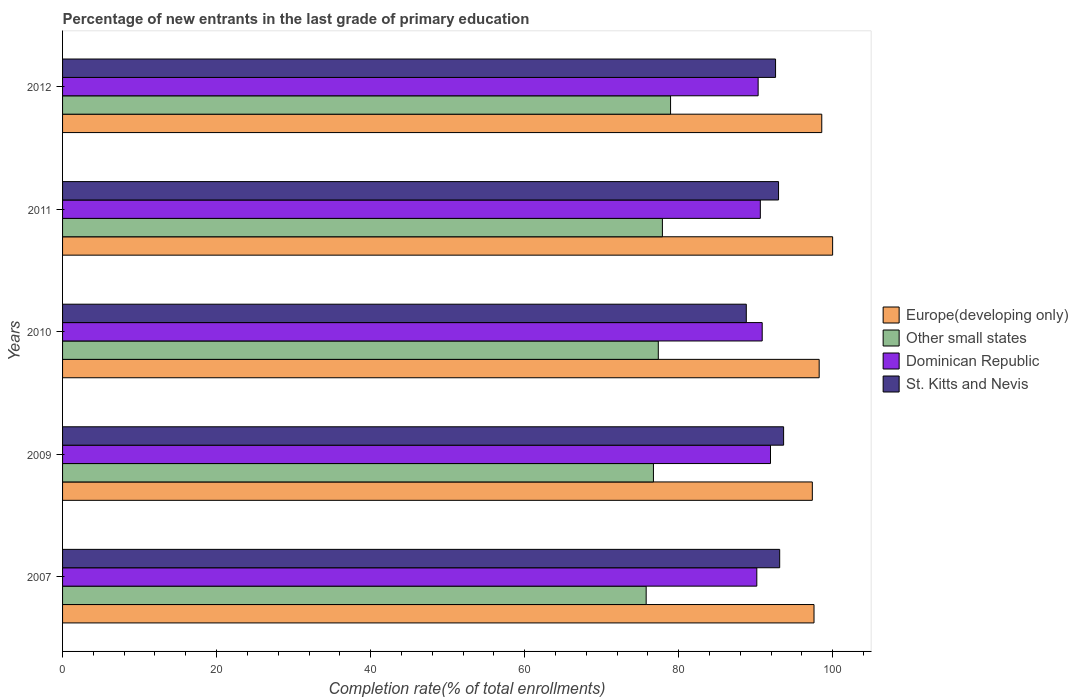Are the number of bars per tick equal to the number of legend labels?
Provide a short and direct response. Yes. Are the number of bars on each tick of the Y-axis equal?
Provide a short and direct response. Yes. How many bars are there on the 4th tick from the top?
Offer a very short reply. 4. How many bars are there on the 3rd tick from the bottom?
Ensure brevity in your answer.  4. What is the label of the 4th group of bars from the top?
Offer a terse response. 2009. In how many cases, is the number of bars for a given year not equal to the number of legend labels?
Offer a terse response. 0. What is the percentage of new entrants in Europe(developing only) in 2007?
Provide a short and direct response. 97.56. Across all years, what is the maximum percentage of new entrants in Europe(developing only)?
Your answer should be very brief. 99.98. Across all years, what is the minimum percentage of new entrants in St. Kitts and Nevis?
Provide a short and direct response. 88.77. What is the total percentage of new entrants in Other small states in the graph?
Make the answer very short. 386.66. What is the difference between the percentage of new entrants in Other small states in 2010 and that in 2011?
Give a very brief answer. -0.53. What is the difference between the percentage of new entrants in Dominican Republic in 2010 and the percentage of new entrants in St. Kitts and Nevis in 2011?
Offer a terse response. -2.12. What is the average percentage of new entrants in Dominican Republic per year?
Keep it short and to the point. 90.76. In the year 2011, what is the difference between the percentage of new entrants in Europe(developing only) and percentage of new entrants in Other small states?
Provide a succinct answer. 22.1. What is the ratio of the percentage of new entrants in Dominican Republic in 2009 to that in 2011?
Offer a very short reply. 1.01. What is the difference between the highest and the second highest percentage of new entrants in St. Kitts and Nevis?
Offer a terse response. 0.51. What is the difference between the highest and the lowest percentage of new entrants in St. Kitts and Nevis?
Your answer should be compact. 4.84. In how many years, is the percentage of new entrants in St. Kitts and Nevis greater than the average percentage of new entrants in St. Kitts and Nevis taken over all years?
Offer a very short reply. 4. What does the 4th bar from the top in 2012 represents?
Provide a succinct answer. Europe(developing only). What does the 2nd bar from the bottom in 2011 represents?
Offer a very short reply. Other small states. Is it the case that in every year, the sum of the percentage of new entrants in Other small states and percentage of new entrants in St. Kitts and Nevis is greater than the percentage of new entrants in Dominican Republic?
Your answer should be very brief. Yes. Are all the bars in the graph horizontal?
Offer a very short reply. Yes. How many years are there in the graph?
Provide a short and direct response. 5. Are the values on the major ticks of X-axis written in scientific E-notation?
Provide a short and direct response. No. How many legend labels are there?
Your response must be concise. 4. What is the title of the graph?
Keep it short and to the point. Percentage of new entrants in the last grade of primary education. What is the label or title of the X-axis?
Your answer should be compact. Completion rate(% of total enrollments). What is the label or title of the Y-axis?
Your answer should be compact. Years. What is the Completion rate(% of total enrollments) of Europe(developing only) in 2007?
Keep it short and to the point. 97.56. What is the Completion rate(% of total enrollments) of Other small states in 2007?
Your response must be concise. 75.77. What is the Completion rate(% of total enrollments) of Dominican Republic in 2007?
Ensure brevity in your answer.  90.14. What is the Completion rate(% of total enrollments) in St. Kitts and Nevis in 2007?
Your response must be concise. 93.11. What is the Completion rate(% of total enrollments) of Europe(developing only) in 2009?
Offer a very short reply. 97.35. What is the Completion rate(% of total enrollments) in Other small states in 2009?
Make the answer very short. 76.72. What is the Completion rate(% of total enrollments) of Dominican Republic in 2009?
Give a very brief answer. 91.91. What is the Completion rate(% of total enrollments) of St. Kitts and Nevis in 2009?
Offer a very short reply. 93.62. What is the Completion rate(% of total enrollments) in Europe(developing only) in 2010?
Provide a short and direct response. 98.24. What is the Completion rate(% of total enrollments) of Other small states in 2010?
Give a very brief answer. 77.35. What is the Completion rate(% of total enrollments) of Dominican Republic in 2010?
Your response must be concise. 90.84. What is the Completion rate(% of total enrollments) of St. Kitts and Nevis in 2010?
Your answer should be compact. 88.77. What is the Completion rate(% of total enrollments) of Europe(developing only) in 2011?
Give a very brief answer. 99.98. What is the Completion rate(% of total enrollments) of Other small states in 2011?
Your answer should be compact. 77.88. What is the Completion rate(% of total enrollments) of Dominican Republic in 2011?
Ensure brevity in your answer.  90.6. What is the Completion rate(% of total enrollments) in St. Kitts and Nevis in 2011?
Provide a short and direct response. 92.96. What is the Completion rate(% of total enrollments) of Europe(developing only) in 2012?
Ensure brevity in your answer.  98.57. What is the Completion rate(% of total enrollments) in Other small states in 2012?
Your answer should be very brief. 78.94. What is the Completion rate(% of total enrollments) of Dominican Republic in 2012?
Give a very brief answer. 90.31. What is the Completion rate(% of total enrollments) of St. Kitts and Nevis in 2012?
Offer a very short reply. 92.57. Across all years, what is the maximum Completion rate(% of total enrollments) in Europe(developing only)?
Ensure brevity in your answer.  99.98. Across all years, what is the maximum Completion rate(% of total enrollments) in Other small states?
Give a very brief answer. 78.94. Across all years, what is the maximum Completion rate(% of total enrollments) of Dominican Republic?
Provide a short and direct response. 91.91. Across all years, what is the maximum Completion rate(% of total enrollments) of St. Kitts and Nevis?
Ensure brevity in your answer.  93.62. Across all years, what is the minimum Completion rate(% of total enrollments) in Europe(developing only)?
Ensure brevity in your answer.  97.35. Across all years, what is the minimum Completion rate(% of total enrollments) of Other small states?
Give a very brief answer. 75.77. Across all years, what is the minimum Completion rate(% of total enrollments) of Dominican Republic?
Provide a short and direct response. 90.14. Across all years, what is the minimum Completion rate(% of total enrollments) in St. Kitts and Nevis?
Offer a terse response. 88.77. What is the total Completion rate(% of total enrollments) of Europe(developing only) in the graph?
Your response must be concise. 491.7. What is the total Completion rate(% of total enrollments) of Other small states in the graph?
Your response must be concise. 386.66. What is the total Completion rate(% of total enrollments) in Dominican Republic in the graph?
Your answer should be compact. 453.8. What is the total Completion rate(% of total enrollments) in St. Kitts and Nevis in the graph?
Your answer should be compact. 461.03. What is the difference between the Completion rate(% of total enrollments) of Europe(developing only) in 2007 and that in 2009?
Provide a short and direct response. 0.22. What is the difference between the Completion rate(% of total enrollments) of Other small states in 2007 and that in 2009?
Your answer should be compact. -0.94. What is the difference between the Completion rate(% of total enrollments) in Dominican Republic in 2007 and that in 2009?
Give a very brief answer. -1.78. What is the difference between the Completion rate(% of total enrollments) in St. Kitts and Nevis in 2007 and that in 2009?
Keep it short and to the point. -0.51. What is the difference between the Completion rate(% of total enrollments) in Europe(developing only) in 2007 and that in 2010?
Ensure brevity in your answer.  -0.67. What is the difference between the Completion rate(% of total enrollments) of Other small states in 2007 and that in 2010?
Your answer should be very brief. -1.57. What is the difference between the Completion rate(% of total enrollments) of Dominican Republic in 2007 and that in 2010?
Provide a short and direct response. -0.7. What is the difference between the Completion rate(% of total enrollments) of St. Kitts and Nevis in 2007 and that in 2010?
Offer a very short reply. 4.33. What is the difference between the Completion rate(% of total enrollments) of Europe(developing only) in 2007 and that in 2011?
Offer a terse response. -2.42. What is the difference between the Completion rate(% of total enrollments) of Other small states in 2007 and that in 2011?
Keep it short and to the point. -2.11. What is the difference between the Completion rate(% of total enrollments) in Dominican Republic in 2007 and that in 2011?
Offer a terse response. -0.46. What is the difference between the Completion rate(% of total enrollments) of St. Kitts and Nevis in 2007 and that in 2011?
Ensure brevity in your answer.  0.15. What is the difference between the Completion rate(% of total enrollments) in Europe(developing only) in 2007 and that in 2012?
Keep it short and to the point. -1.01. What is the difference between the Completion rate(% of total enrollments) of Other small states in 2007 and that in 2012?
Offer a terse response. -3.17. What is the difference between the Completion rate(% of total enrollments) of Dominican Republic in 2007 and that in 2012?
Your answer should be very brief. -0.17. What is the difference between the Completion rate(% of total enrollments) in St. Kitts and Nevis in 2007 and that in 2012?
Provide a short and direct response. 0.53. What is the difference between the Completion rate(% of total enrollments) of Europe(developing only) in 2009 and that in 2010?
Your response must be concise. -0.89. What is the difference between the Completion rate(% of total enrollments) in Other small states in 2009 and that in 2010?
Give a very brief answer. -0.63. What is the difference between the Completion rate(% of total enrollments) in Dominican Republic in 2009 and that in 2010?
Provide a succinct answer. 1.08. What is the difference between the Completion rate(% of total enrollments) in St. Kitts and Nevis in 2009 and that in 2010?
Provide a succinct answer. 4.84. What is the difference between the Completion rate(% of total enrollments) in Europe(developing only) in 2009 and that in 2011?
Give a very brief answer. -2.64. What is the difference between the Completion rate(% of total enrollments) in Other small states in 2009 and that in 2011?
Provide a short and direct response. -1.17. What is the difference between the Completion rate(% of total enrollments) of Dominican Republic in 2009 and that in 2011?
Provide a succinct answer. 1.32. What is the difference between the Completion rate(% of total enrollments) in St. Kitts and Nevis in 2009 and that in 2011?
Give a very brief answer. 0.66. What is the difference between the Completion rate(% of total enrollments) in Europe(developing only) in 2009 and that in 2012?
Your response must be concise. -1.23. What is the difference between the Completion rate(% of total enrollments) of Other small states in 2009 and that in 2012?
Your answer should be very brief. -2.22. What is the difference between the Completion rate(% of total enrollments) of Dominican Republic in 2009 and that in 2012?
Provide a short and direct response. 1.61. What is the difference between the Completion rate(% of total enrollments) in St. Kitts and Nevis in 2009 and that in 2012?
Provide a succinct answer. 1.04. What is the difference between the Completion rate(% of total enrollments) of Europe(developing only) in 2010 and that in 2011?
Give a very brief answer. -1.75. What is the difference between the Completion rate(% of total enrollments) in Other small states in 2010 and that in 2011?
Make the answer very short. -0.53. What is the difference between the Completion rate(% of total enrollments) of Dominican Republic in 2010 and that in 2011?
Give a very brief answer. 0.24. What is the difference between the Completion rate(% of total enrollments) in St. Kitts and Nevis in 2010 and that in 2011?
Provide a succinct answer. -4.19. What is the difference between the Completion rate(% of total enrollments) in Europe(developing only) in 2010 and that in 2012?
Keep it short and to the point. -0.34. What is the difference between the Completion rate(% of total enrollments) of Other small states in 2010 and that in 2012?
Offer a terse response. -1.59. What is the difference between the Completion rate(% of total enrollments) of Dominican Republic in 2010 and that in 2012?
Make the answer very short. 0.53. What is the difference between the Completion rate(% of total enrollments) in St. Kitts and Nevis in 2010 and that in 2012?
Provide a short and direct response. -3.8. What is the difference between the Completion rate(% of total enrollments) of Europe(developing only) in 2011 and that in 2012?
Provide a short and direct response. 1.41. What is the difference between the Completion rate(% of total enrollments) in Other small states in 2011 and that in 2012?
Give a very brief answer. -1.06. What is the difference between the Completion rate(% of total enrollments) of Dominican Republic in 2011 and that in 2012?
Provide a short and direct response. 0.29. What is the difference between the Completion rate(% of total enrollments) of St. Kitts and Nevis in 2011 and that in 2012?
Provide a succinct answer. 0.39. What is the difference between the Completion rate(% of total enrollments) in Europe(developing only) in 2007 and the Completion rate(% of total enrollments) in Other small states in 2009?
Make the answer very short. 20.85. What is the difference between the Completion rate(% of total enrollments) in Europe(developing only) in 2007 and the Completion rate(% of total enrollments) in Dominican Republic in 2009?
Your response must be concise. 5.65. What is the difference between the Completion rate(% of total enrollments) of Europe(developing only) in 2007 and the Completion rate(% of total enrollments) of St. Kitts and Nevis in 2009?
Provide a short and direct response. 3.95. What is the difference between the Completion rate(% of total enrollments) in Other small states in 2007 and the Completion rate(% of total enrollments) in Dominican Republic in 2009?
Your answer should be compact. -16.14. What is the difference between the Completion rate(% of total enrollments) of Other small states in 2007 and the Completion rate(% of total enrollments) of St. Kitts and Nevis in 2009?
Your answer should be compact. -17.84. What is the difference between the Completion rate(% of total enrollments) in Dominican Republic in 2007 and the Completion rate(% of total enrollments) in St. Kitts and Nevis in 2009?
Give a very brief answer. -3.48. What is the difference between the Completion rate(% of total enrollments) in Europe(developing only) in 2007 and the Completion rate(% of total enrollments) in Other small states in 2010?
Provide a short and direct response. 20.22. What is the difference between the Completion rate(% of total enrollments) of Europe(developing only) in 2007 and the Completion rate(% of total enrollments) of Dominican Republic in 2010?
Provide a succinct answer. 6.73. What is the difference between the Completion rate(% of total enrollments) in Europe(developing only) in 2007 and the Completion rate(% of total enrollments) in St. Kitts and Nevis in 2010?
Your answer should be compact. 8.79. What is the difference between the Completion rate(% of total enrollments) in Other small states in 2007 and the Completion rate(% of total enrollments) in Dominican Republic in 2010?
Your answer should be compact. -15.07. What is the difference between the Completion rate(% of total enrollments) in Other small states in 2007 and the Completion rate(% of total enrollments) in St. Kitts and Nevis in 2010?
Provide a short and direct response. -13. What is the difference between the Completion rate(% of total enrollments) in Dominican Republic in 2007 and the Completion rate(% of total enrollments) in St. Kitts and Nevis in 2010?
Offer a terse response. 1.36. What is the difference between the Completion rate(% of total enrollments) in Europe(developing only) in 2007 and the Completion rate(% of total enrollments) in Other small states in 2011?
Your answer should be compact. 19.68. What is the difference between the Completion rate(% of total enrollments) in Europe(developing only) in 2007 and the Completion rate(% of total enrollments) in Dominican Republic in 2011?
Ensure brevity in your answer.  6.97. What is the difference between the Completion rate(% of total enrollments) in Europe(developing only) in 2007 and the Completion rate(% of total enrollments) in St. Kitts and Nevis in 2011?
Your answer should be compact. 4.6. What is the difference between the Completion rate(% of total enrollments) in Other small states in 2007 and the Completion rate(% of total enrollments) in Dominican Republic in 2011?
Your response must be concise. -14.82. What is the difference between the Completion rate(% of total enrollments) of Other small states in 2007 and the Completion rate(% of total enrollments) of St. Kitts and Nevis in 2011?
Offer a very short reply. -17.19. What is the difference between the Completion rate(% of total enrollments) of Dominican Republic in 2007 and the Completion rate(% of total enrollments) of St. Kitts and Nevis in 2011?
Offer a terse response. -2.82. What is the difference between the Completion rate(% of total enrollments) of Europe(developing only) in 2007 and the Completion rate(% of total enrollments) of Other small states in 2012?
Keep it short and to the point. 18.62. What is the difference between the Completion rate(% of total enrollments) of Europe(developing only) in 2007 and the Completion rate(% of total enrollments) of Dominican Republic in 2012?
Your response must be concise. 7.25. What is the difference between the Completion rate(% of total enrollments) in Europe(developing only) in 2007 and the Completion rate(% of total enrollments) in St. Kitts and Nevis in 2012?
Provide a short and direct response. 4.99. What is the difference between the Completion rate(% of total enrollments) in Other small states in 2007 and the Completion rate(% of total enrollments) in Dominican Republic in 2012?
Give a very brief answer. -14.54. What is the difference between the Completion rate(% of total enrollments) in Other small states in 2007 and the Completion rate(% of total enrollments) in St. Kitts and Nevis in 2012?
Offer a terse response. -16.8. What is the difference between the Completion rate(% of total enrollments) in Dominican Republic in 2007 and the Completion rate(% of total enrollments) in St. Kitts and Nevis in 2012?
Your answer should be very brief. -2.44. What is the difference between the Completion rate(% of total enrollments) in Europe(developing only) in 2009 and the Completion rate(% of total enrollments) in Other small states in 2010?
Keep it short and to the point. 20. What is the difference between the Completion rate(% of total enrollments) in Europe(developing only) in 2009 and the Completion rate(% of total enrollments) in Dominican Republic in 2010?
Provide a succinct answer. 6.51. What is the difference between the Completion rate(% of total enrollments) in Europe(developing only) in 2009 and the Completion rate(% of total enrollments) in St. Kitts and Nevis in 2010?
Ensure brevity in your answer.  8.57. What is the difference between the Completion rate(% of total enrollments) in Other small states in 2009 and the Completion rate(% of total enrollments) in Dominican Republic in 2010?
Offer a terse response. -14.12. What is the difference between the Completion rate(% of total enrollments) of Other small states in 2009 and the Completion rate(% of total enrollments) of St. Kitts and Nevis in 2010?
Provide a short and direct response. -12.06. What is the difference between the Completion rate(% of total enrollments) of Dominican Republic in 2009 and the Completion rate(% of total enrollments) of St. Kitts and Nevis in 2010?
Keep it short and to the point. 3.14. What is the difference between the Completion rate(% of total enrollments) in Europe(developing only) in 2009 and the Completion rate(% of total enrollments) in Other small states in 2011?
Make the answer very short. 19.47. What is the difference between the Completion rate(% of total enrollments) of Europe(developing only) in 2009 and the Completion rate(% of total enrollments) of Dominican Republic in 2011?
Ensure brevity in your answer.  6.75. What is the difference between the Completion rate(% of total enrollments) in Europe(developing only) in 2009 and the Completion rate(% of total enrollments) in St. Kitts and Nevis in 2011?
Offer a very short reply. 4.39. What is the difference between the Completion rate(% of total enrollments) in Other small states in 2009 and the Completion rate(% of total enrollments) in Dominican Republic in 2011?
Keep it short and to the point. -13.88. What is the difference between the Completion rate(% of total enrollments) in Other small states in 2009 and the Completion rate(% of total enrollments) in St. Kitts and Nevis in 2011?
Your answer should be very brief. -16.24. What is the difference between the Completion rate(% of total enrollments) in Dominican Republic in 2009 and the Completion rate(% of total enrollments) in St. Kitts and Nevis in 2011?
Your answer should be compact. -1.05. What is the difference between the Completion rate(% of total enrollments) of Europe(developing only) in 2009 and the Completion rate(% of total enrollments) of Other small states in 2012?
Provide a succinct answer. 18.41. What is the difference between the Completion rate(% of total enrollments) of Europe(developing only) in 2009 and the Completion rate(% of total enrollments) of Dominican Republic in 2012?
Keep it short and to the point. 7.04. What is the difference between the Completion rate(% of total enrollments) of Europe(developing only) in 2009 and the Completion rate(% of total enrollments) of St. Kitts and Nevis in 2012?
Your answer should be compact. 4.77. What is the difference between the Completion rate(% of total enrollments) in Other small states in 2009 and the Completion rate(% of total enrollments) in Dominican Republic in 2012?
Ensure brevity in your answer.  -13.59. What is the difference between the Completion rate(% of total enrollments) of Other small states in 2009 and the Completion rate(% of total enrollments) of St. Kitts and Nevis in 2012?
Ensure brevity in your answer.  -15.86. What is the difference between the Completion rate(% of total enrollments) in Dominican Republic in 2009 and the Completion rate(% of total enrollments) in St. Kitts and Nevis in 2012?
Your answer should be compact. -0.66. What is the difference between the Completion rate(% of total enrollments) of Europe(developing only) in 2010 and the Completion rate(% of total enrollments) of Other small states in 2011?
Give a very brief answer. 20.35. What is the difference between the Completion rate(% of total enrollments) in Europe(developing only) in 2010 and the Completion rate(% of total enrollments) in Dominican Republic in 2011?
Your answer should be compact. 7.64. What is the difference between the Completion rate(% of total enrollments) of Europe(developing only) in 2010 and the Completion rate(% of total enrollments) of St. Kitts and Nevis in 2011?
Provide a short and direct response. 5.27. What is the difference between the Completion rate(% of total enrollments) in Other small states in 2010 and the Completion rate(% of total enrollments) in Dominican Republic in 2011?
Give a very brief answer. -13.25. What is the difference between the Completion rate(% of total enrollments) in Other small states in 2010 and the Completion rate(% of total enrollments) in St. Kitts and Nevis in 2011?
Keep it short and to the point. -15.61. What is the difference between the Completion rate(% of total enrollments) of Dominican Republic in 2010 and the Completion rate(% of total enrollments) of St. Kitts and Nevis in 2011?
Your response must be concise. -2.12. What is the difference between the Completion rate(% of total enrollments) of Europe(developing only) in 2010 and the Completion rate(% of total enrollments) of Other small states in 2012?
Provide a succinct answer. 19.29. What is the difference between the Completion rate(% of total enrollments) in Europe(developing only) in 2010 and the Completion rate(% of total enrollments) in Dominican Republic in 2012?
Provide a short and direct response. 7.93. What is the difference between the Completion rate(% of total enrollments) in Europe(developing only) in 2010 and the Completion rate(% of total enrollments) in St. Kitts and Nevis in 2012?
Your answer should be very brief. 5.66. What is the difference between the Completion rate(% of total enrollments) in Other small states in 2010 and the Completion rate(% of total enrollments) in Dominican Republic in 2012?
Your response must be concise. -12.96. What is the difference between the Completion rate(% of total enrollments) of Other small states in 2010 and the Completion rate(% of total enrollments) of St. Kitts and Nevis in 2012?
Give a very brief answer. -15.23. What is the difference between the Completion rate(% of total enrollments) of Dominican Republic in 2010 and the Completion rate(% of total enrollments) of St. Kitts and Nevis in 2012?
Keep it short and to the point. -1.74. What is the difference between the Completion rate(% of total enrollments) in Europe(developing only) in 2011 and the Completion rate(% of total enrollments) in Other small states in 2012?
Give a very brief answer. 21.04. What is the difference between the Completion rate(% of total enrollments) in Europe(developing only) in 2011 and the Completion rate(% of total enrollments) in Dominican Republic in 2012?
Your answer should be compact. 9.67. What is the difference between the Completion rate(% of total enrollments) of Europe(developing only) in 2011 and the Completion rate(% of total enrollments) of St. Kitts and Nevis in 2012?
Keep it short and to the point. 7.41. What is the difference between the Completion rate(% of total enrollments) in Other small states in 2011 and the Completion rate(% of total enrollments) in Dominican Republic in 2012?
Make the answer very short. -12.43. What is the difference between the Completion rate(% of total enrollments) of Other small states in 2011 and the Completion rate(% of total enrollments) of St. Kitts and Nevis in 2012?
Your response must be concise. -14.69. What is the difference between the Completion rate(% of total enrollments) in Dominican Republic in 2011 and the Completion rate(% of total enrollments) in St. Kitts and Nevis in 2012?
Ensure brevity in your answer.  -1.98. What is the average Completion rate(% of total enrollments) of Europe(developing only) per year?
Provide a short and direct response. 98.34. What is the average Completion rate(% of total enrollments) in Other small states per year?
Offer a terse response. 77.33. What is the average Completion rate(% of total enrollments) in Dominican Republic per year?
Your answer should be very brief. 90.76. What is the average Completion rate(% of total enrollments) in St. Kitts and Nevis per year?
Your answer should be very brief. 92.21. In the year 2007, what is the difference between the Completion rate(% of total enrollments) in Europe(developing only) and Completion rate(% of total enrollments) in Other small states?
Your response must be concise. 21.79. In the year 2007, what is the difference between the Completion rate(% of total enrollments) in Europe(developing only) and Completion rate(% of total enrollments) in Dominican Republic?
Offer a terse response. 7.43. In the year 2007, what is the difference between the Completion rate(% of total enrollments) of Europe(developing only) and Completion rate(% of total enrollments) of St. Kitts and Nevis?
Provide a succinct answer. 4.46. In the year 2007, what is the difference between the Completion rate(% of total enrollments) in Other small states and Completion rate(% of total enrollments) in Dominican Republic?
Make the answer very short. -14.37. In the year 2007, what is the difference between the Completion rate(% of total enrollments) of Other small states and Completion rate(% of total enrollments) of St. Kitts and Nevis?
Offer a terse response. -17.34. In the year 2007, what is the difference between the Completion rate(% of total enrollments) in Dominican Republic and Completion rate(% of total enrollments) in St. Kitts and Nevis?
Your answer should be very brief. -2.97. In the year 2009, what is the difference between the Completion rate(% of total enrollments) of Europe(developing only) and Completion rate(% of total enrollments) of Other small states?
Keep it short and to the point. 20.63. In the year 2009, what is the difference between the Completion rate(% of total enrollments) of Europe(developing only) and Completion rate(% of total enrollments) of Dominican Republic?
Offer a terse response. 5.43. In the year 2009, what is the difference between the Completion rate(% of total enrollments) in Europe(developing only) and Completion rate(% of total enrollments) in St. Kitts and Nevis?
Give a very brief answer. 3.73. In the year 2009, what is the difference between the Completion rate(% of total enrollments) of Other small states and Completion rate(% of total enrollments) of Dominican Republic?
Provide a short and direct response. -15.2. In the year 2009, what is the difference between the Completion rate(% of total enrollments) in Other small states and Completion rate(% of total enrollments) in St. Kitts and Nevis?
Your response must be concise. -16.9. In the year 2009, what is the difference between the Completion rate(% of total enrollments) in Dominican Republic and Completion rate(% of total enrollments) in St. Kitts and Nevis?
Your answer should be compact. -1.7. In the year 2010, what is the difference between the Completion rate(% of total enrollments) in Europe(developing only) and Completion rate(% of total enrollments) in Other small states?
Your answer should be compact. 20.89. In the year 2010, what is the difference between the Completion rate(% of total enrollments) of Europe(developing only) and Completion rate(% of total enrollments) of Dominican Republic?
Provide a succinct answer. 7.4. In the year 2010, what is the difference between the Completion rate(% of total enrollments) in Europe(developing only) and Completion rate(% of total enrollments) in St. Kitts and Nevis?
Ensure brevity in your answer.  9.46. In the year 2010, what is the difference between the Completion rate(% of total enrollments) of Other small states and Completion rate(% of total enrollments) of Dominican Republic?
Provide a short and direct response. -13.49. In the year 2010, what is the difference between the Completion rate(% of total enrollments) of Other small states and Completion rate(% of total enrollments) of St. Kitts and Nevis?
Your answer should be compact. -11.43. In the year 2010, what is the difference between the Completion rate(% of total enrollments) in Dominican Republic and Completion rate(% of total enrollments) in St. Kitts and Nevis?
Make the answer very short. 2.06. In the year 2011, what is the difference between the Completion rate(% of total enrollments) in Europe(developing only) and Completion rate(% of total enrollments) in Other small states?
Your answer should be compact. 22.1. In the year 2011, what is the difference between the Completion rate(% of total enrollments) of Europe(developing only) and Completion rate(% of total enrollments) of Dominican Republic?
Give a very brief answer. 9.39. In the year 2011, what is the difference between the Completion rate(% of total enrollments) of Europe(developing only) and Completion rate(% of total enrollments) of St. Kitts and Nevis?
Provide a succinct answer. 7.02. In the year 2011, what is the difference between the Completion rate(% of total enrollments) of Other small states and Completion rate(% of total enrollments) of Dominican Republic?
Your answer should be compact. -12.71. In the year 2011, what is the difference between the Completion rate(% of total enrollments) in Other small states and Completion rate(% of total enrollments) in St. Kitts and Nevis?
Make the answer very short. -15.08. In the year 2011, what is the difference between the Completion rate(% of total enrollments) of Dominican Republic and Completion rate(% of total enrollments) of St. Kitts and Nevis?
Offer a very short reply. -2.37. In the year 2012, what is the difference between the Completion rate(% of total enrollments) of Europe(developing only) and Completion rate(% of total enrollments) of Other small states?
Give a very brief answer. 19.63. In the year 2012, what is the difference between the Completion rate(% of total enrollments) of Europe(developing only) and Completion rate(% of total enrollments) of Dominican Republic?
Offer a terse response. 8.26. In the year 2012, what is the difference between the Completion rate(% of total enrollments) of Europe(developing only) and Completion rate(% of total enrollments) of St. Kitts and Nevis?
Provide a short and direct response. 6. In the year 2012, what is the difference between the Completion rate(% of total enrollments) of Other small states and Completion rate(% of total enrollments) of Dominican Republic?
Provide a short and direct response. -11.37. In the year 2012, what is the difference between the Completion rate(% of total enrollments) in Other small states and Completion rate(% of total enrollments) in St. Kitts and Nevis?
Ensure brevity in your answer.  -13.63. In the year 2012, what is the difference between the Completion rate(% of total enrollments) in Dominican Republic and Completion rate(% of total enrollments) in St. Kitts and Nevis?
Your response must be concise. -2.26. What is the ratio of the Completion rate(% of total enrollments) in Europe(developing only) in 2007 to that in 2009?
Keep it short and to the point. 1. What is the ratio of the Completion rate(% of total enrollments) in Other small states in 2007 to that in 2009?
Your answer should be very brief. 0.99. What is the ratio of the Completion rate(% of total enrollments) in Dominican Republic in 2007 to that in 2009?
Your answer should be compact. 0.98. What is the ratio of the Completion rate(% of total enrollments) in St. Kitts and Nevis in 2007 to that in 2009?
Offer a very short reply. 0.99. What is the ratio of the Completion rate(% of total enrollments) in Europe(developing only) in 2007 to that in 2010?
Ensure brevity in your answer.  0.99. What is the ratio of the Completion rate(% of total enrollments) in Other small states in 2007 to that in 2010?
Provide a short and direct response. 0.98. What is the ratio of the Completion rate(% of total enrollments) in Dominican Republic in 2007 to that in 2010?
Your response must be concise. 0.99. What is the ratio of the Completion rate(% of total enrollments) in St. Kitts and Nevis in 2007 to that in 2010?
Offer a terse response. 1.05. What is the ratio of the Completion rate(% of total enrollments) of Europe(developing only) in 2007 to that in 2011?
Make the answer very short. 0.98. What is the ratio of the Completion rate(% of total enrollments) in Other small states in 2007 to that in 2011?
Give a very brief answer. 0.97. What is the ratio of the Completion rate(% of total enrollments) in St. Kitts and Nevis in 2007 to that in 2011?
Make the answer very short. 1. What is the ratio of the Completion rate(% of total enrollments) of Other small states in 2007 to that in 2012?
Give a very brief answer. 0.96. What is the ratio of the Completion rate(% of total enrollments) of St. Kitts and Nevis in 2007 to that in 2012?
Your response must be concise. 1.01. What is the ratio of the Completion rate(% of total enrollments) in Dominican Republic in 2009 to that in 2010?
Your response must be concise. 1.01. What is the ratio of the Completion rate(% of total enrollments) of St. Kitts and Nevis in 2009 to that in 2010?
Give a very brief answer. 1.05. What is the ratio of the Completion rate(% of total enrollments) of Europe(developing only) in 2009 to that in 2011?
Your response must be concise. 0.97. What is the ratio of the Completion rate(% of total enrollments) in Dominican Republic in 2009 to that in 2011?
Keep it short and to the point. 1.01. What is the ratio of the Completion rate(% of total enrollments) of St. Kitts and Nevis in 2009 to that in 2011?
Your answer should be compact. 1.01. What is the ratio of the Completion rate(% of total enrollments) in Europe(developing only) in 2009 to that in 2012?
Your answer should be compact. 0.99. What is the ratio of the Completion rate(% of total enrollments) of Other small states in 2009 to that in 2012?
Keep it short and to the point. 0.97. What is the ratio of the Completion rate(% of total enrollments) of Dominican Republic in 2009 to that in 2012?
Give a very brief answer. 1.02. What is the ratio of the Completion rate(% of total enrollments) of St. Kitts and Nevis in 2009 to that in 2012?
Ensure brevity in your answer.  1.01. What is the ratio of the Completion rate(% of total enrollments) in Europe(developing only) in 2010 to that in 2011?
Make the answer very short. 0.98. What is the ratio of the Completion rate(% of total enrollments) of St. Kitts and Nevis in 2010 to that in 2011?
Offer a terse response. 0.95. What is the ratio of the Completion rate(% of total enrollments) in Europe(developing only) in 2010 to that in 2012?
Provide a succinct answer. 1. What is the ratio of the Completion rate(% of total enrollments) in Other small states in 2010 to that in 2012?
Your answer should be compact. 0.98. What is the ratio of the Completion rate(% of total enrollments) of Europe(developing only) in 2011 to that in 2012?
Provide a short and direct response. 1.01. What is the ratio of the Completion rate(% of total enrollments) in Other small states in 2011 to that in 2012?
Your answer should be very brief. 0.99. What is the difference between the highest and the second highest Completion rate(% of total enrollments) in Europe(developing only)?
Make the answer very short. 1.41. What is the difference between the highest and the second highest Completion rate(% of total enrollments) of Other small states?
Keep it short and to the point. 1.06. What is the difference between the highest and the second highest Completion rate(% of total enrollments) in Dominican Republic?
Offer a terse response. 1.08. What is the difference between the highest and the second highest Completion rate(% of total enrollments) of St. Kitts and Nevis?
Ensure brevity in your answer.  0.51. What is the difference between the highest and the lowest Completion rate(% of total enrollments) of Europe(developing only)?
Provide a short and direct response. 2.64. What is the difference between the highest and the lowest Completion rate(% of total enrollments) in Other small states?
Give a very brief answer. 3.17. What is the difference between the highest and the lowest Completion rate(% of total enrollments) in Dominican Republic?
Make the answer very short. 1.78. What is the difference between the highest and the lowest Completion rate(% of total enrollments) of St. Kitts and Nevis?
Give a very brief answer. 4.84. 